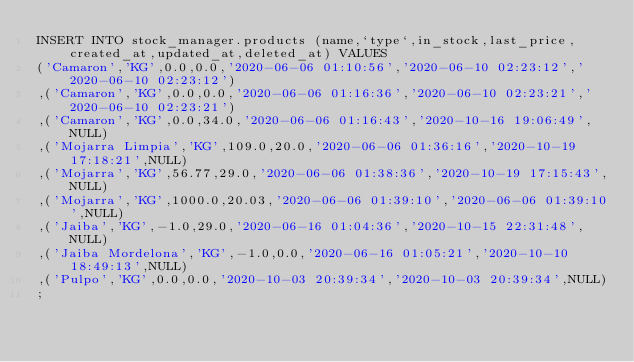<code> <loc_0><loc_0><loc_500><loc_500><_SQL_>INSERT INTO stock_manager.products (name,`type`,in_stock,last_price,created_at,updated_at,deleted_at) VALUES 
('Camaron','KG',0.0,0.0,'2020-06-06 01:10:56','2020-06-10 02:23:12','2020-06-10 02:23:12')
,('Camaron','KG',0.0,0.0,'2020-06-06 01:16:36','2020-06-10 02:23:21','2020-06-10 02:23:21')
,('Camaron','KG',0.0,34.0,'2020-06-06 01:16:43','2020-10-16 19:06:49',NULL)
,('Mojarra Limpia','KG',109.0,20.0,'2020-06-06 01:36:16','2020-10-19 17:18:21',NULL)
,('Mojarra','KG',56.77,29.0,'2020-06-06 01:38:36','2020-10-19 17:15:43',NULL)
,('Mojarra','KG',1000.0,20.03,'2020-06-06 01:39:10','2020-06-06 01:39:10',NULL)
,('Jaiba','KG',-1.0,29.0,'2020-06-16 01:04:36','2020-10-15 22:31:48',NULL)
,('Jaiba Mordelona','KG',-1.0,0.0,'2020-06-16 01:05:21','2020-10-10 18:49:13',NULL)
,('Pulpo','KG',0.0,0.0,'2020-10-03 20:39:34','2020-10-03 20:39:34',NULL)
;</code> 